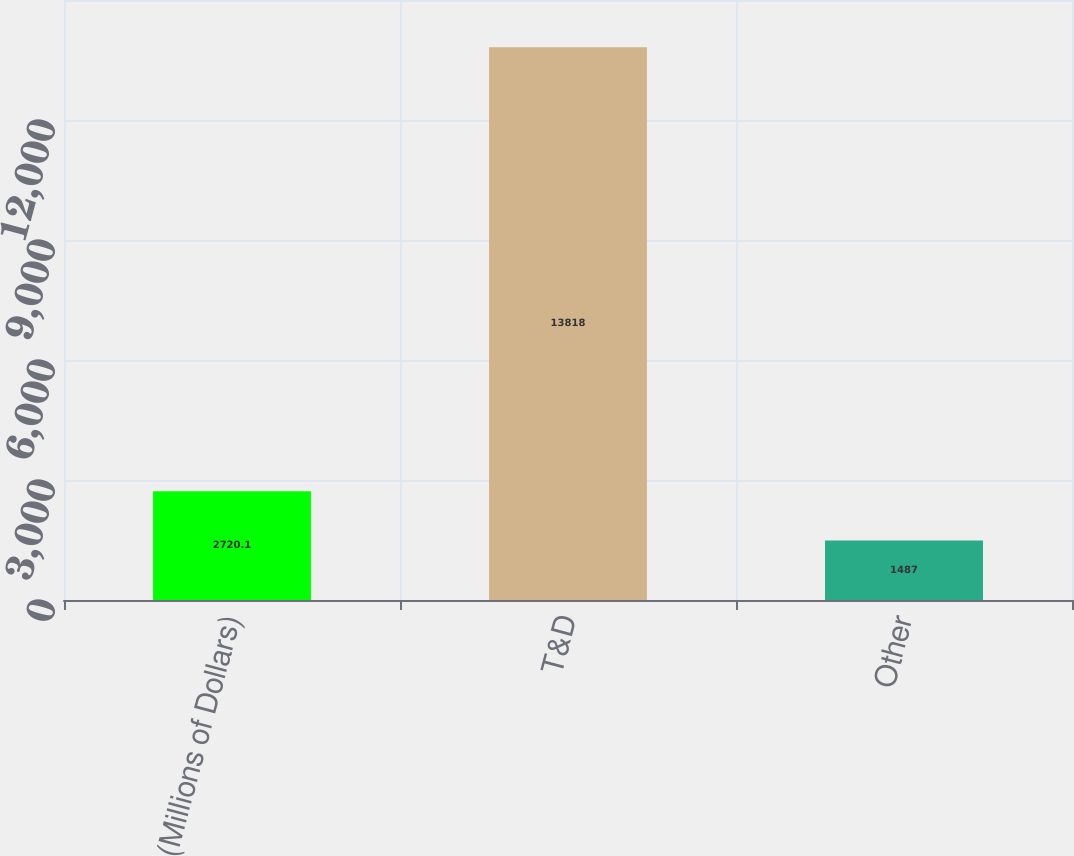Convert chart to OTSL. <chart><loc_0><loc_0><loc_500><loc_500><bar_chart><fcel>(Millions of Dollars)<fcel>T&D<fcel>Other<nl><fcel>2720.1<fcel>13818<fcel>1487<nl></chart> 